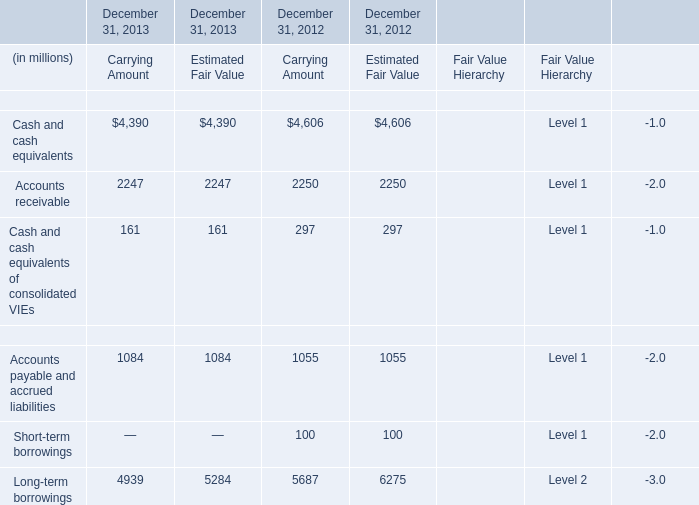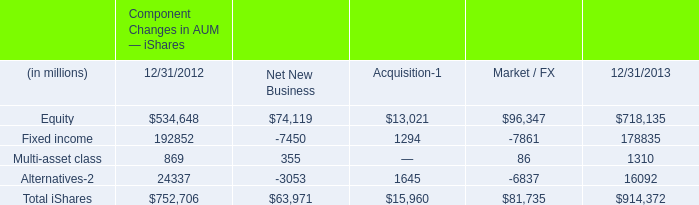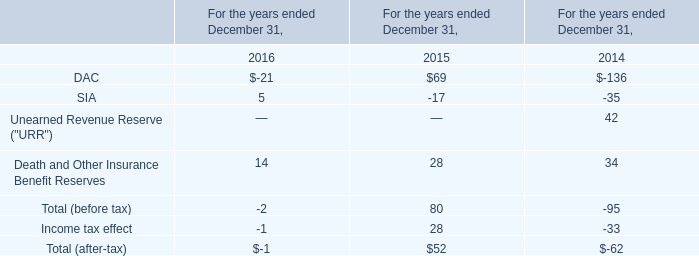In what year is Cash and cash equivalents of consolidated VIEs for carrying amount greater than 200? 
Answer: 2012. 